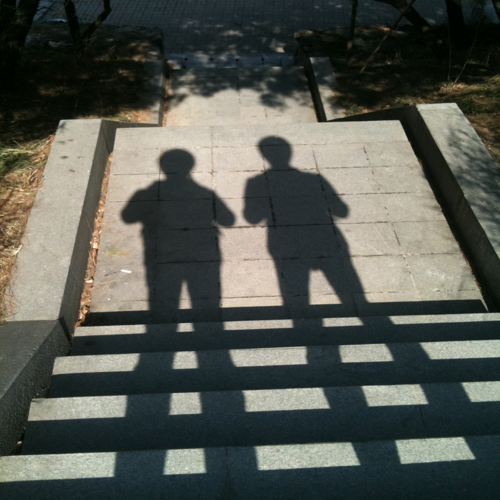What time of day does this image suggest? The long and well-defined shadows in the image suggest that the photo was taken in the early morning or late afternoon when the sun is lower in the sky. 